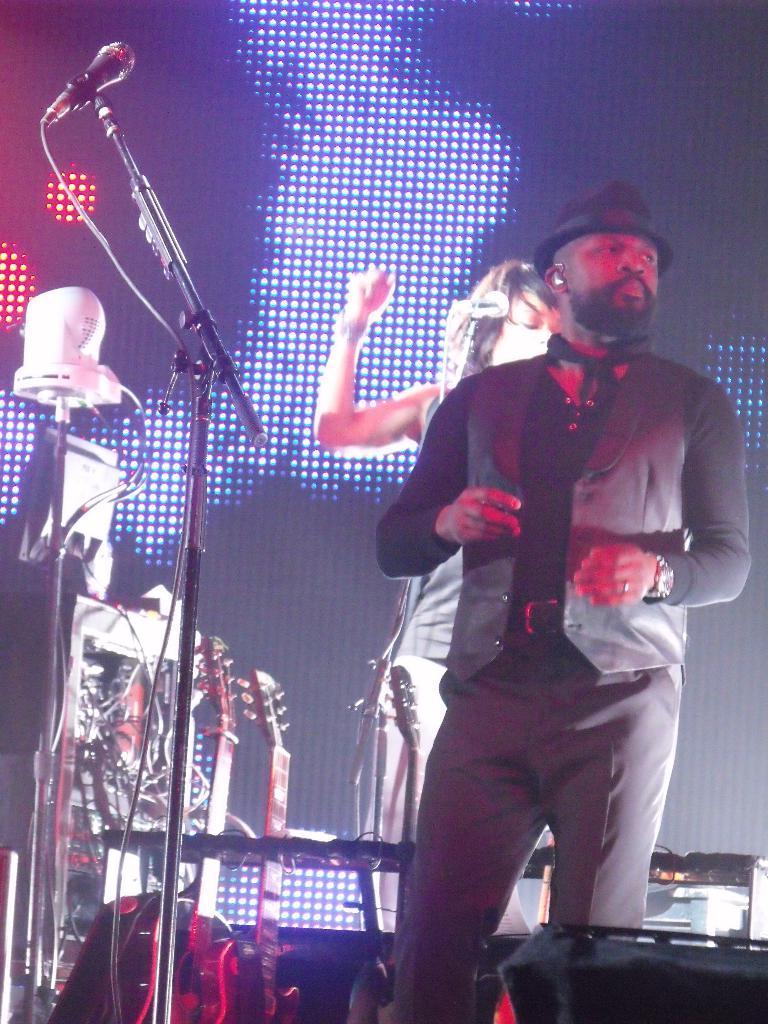Could you give a brief overview of what you see in this image? In this image I can see two people with black and grey color dresses. I can see one person is wearing the hat. To the side of these people I can see the mic and some musical instruments. In the back I can see the lights. 